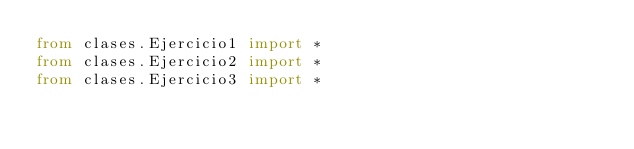<code> <loc_0><loc_0><loc_500><loc_500><_Python_>from clases.Ejercicio1 import *
from clases.Ejercicio2 import *
from clases.Ejercicio3 import *</code> 